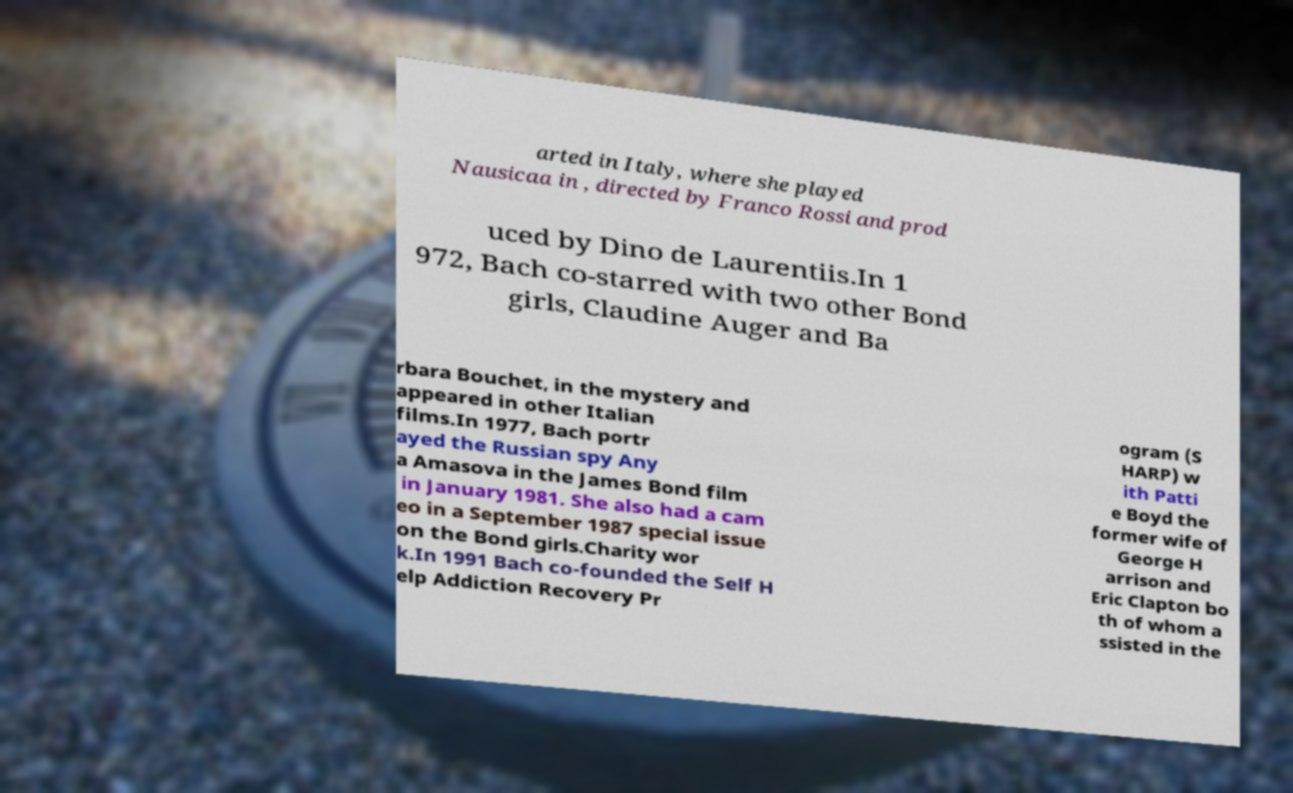What messages or text are displayed in this image? I need them in a readable, typed format. arted in Italy, where she played Nausicaa in , directed by Franco Rossi and prod uced by Dino de Laurentiis.In 1 972, Bach co-starred with two other Bond girls, Claudine Auger and Ba rbara Bouchet, in the mystery and appeared in other Italian films.In 1977, Bach portr ayed the Russian spy Any a Amasova in the James Bond film in January 1981. She also had a cam eo in a September 1987 special issue on the Bond girls.Charity wor k.In 1991 Bach co-founded the Self H elp Addiction Recovery Pr ogram (S HARP) w ith Patti e Boyd the former wife of George H arrison and Eric Clapton bo th of whom a ssisted in the 